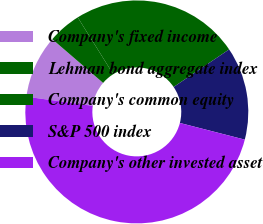Convert chart. <chart><loc_0><loc_0><loc_500><loc_500><pie_chart><fcel>Company's fixed income<fcel>Lehman bond aggregate index<fcel>Company's common equity<fcel>S&P 500 index<fcel>Company's other invested asset<nl><fcel>9.13%<fcel>4.8%<fcel>24.42%<fcel>13.47%<fcel>48.18%<nl></chart> 